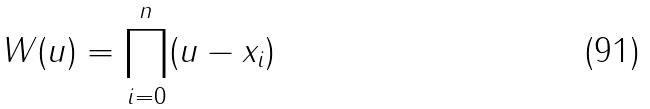<formula> <loc_0><loc_0><loc_500><loc_500>W ( u ) = \prod _ { i = 0 } ^ { n } ( u - x _ { i } )</formula> 